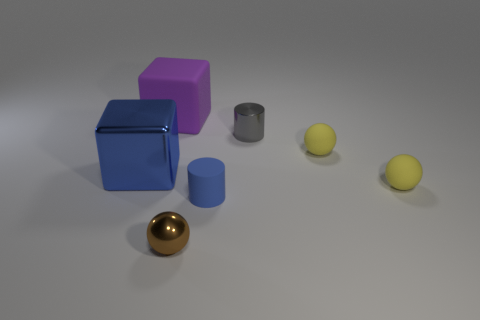Add 3 large blue metallic things. How many objects exist? 10 Subtract all blue cubes. Subtract all gray cylinders. How many cubes are left? 1 Subtract all cubes. How many objects are left? 5 Add 4 big shiny blocks. How many big shiny blocks are left? 5 Add 7 large cyan cubes. How many large cyan cubes exist? 7 Subtract 0 green cubes. How many objects are left? 7 Subtract all brown metallic objects. Subtract all matte cylinders. How many objects are left? 5 